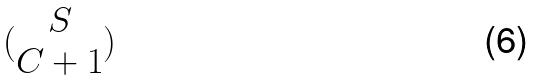Convert formula to latex. <formula><loc_0><loc_0><loc_500><loc_500>( \begin{matrix} S \\ C + 1 \end{matrix} )</formula> 